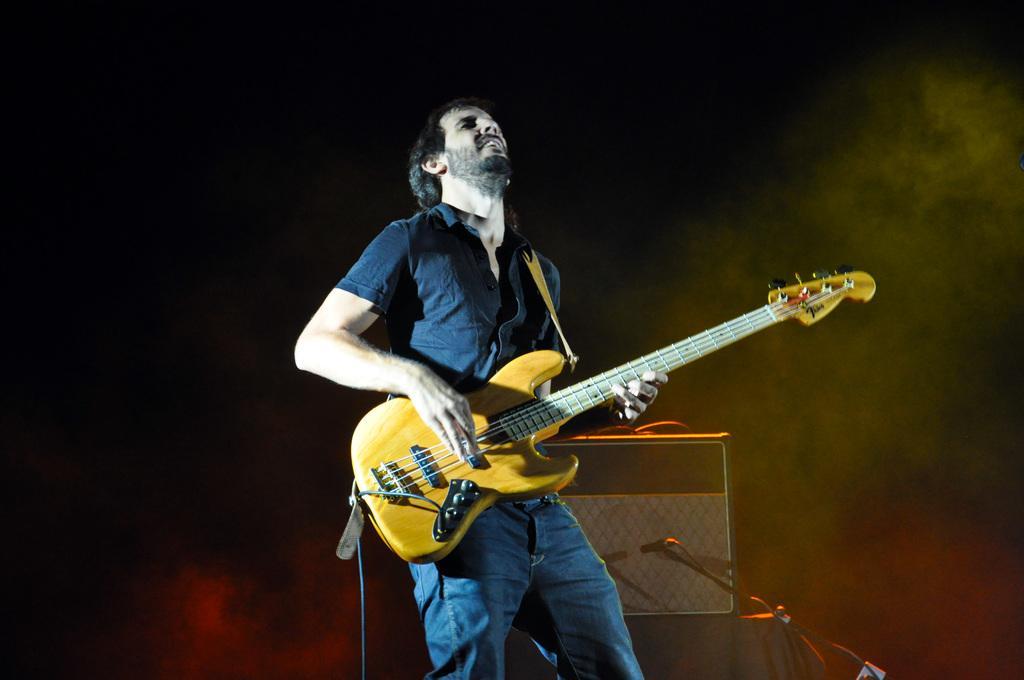How would you summarize this image in a sentence or two? In the center of the image we can see a man is standing and holding a guitar in his hand. In the middle of the image we can see a musical instrument, mic stand are present. 